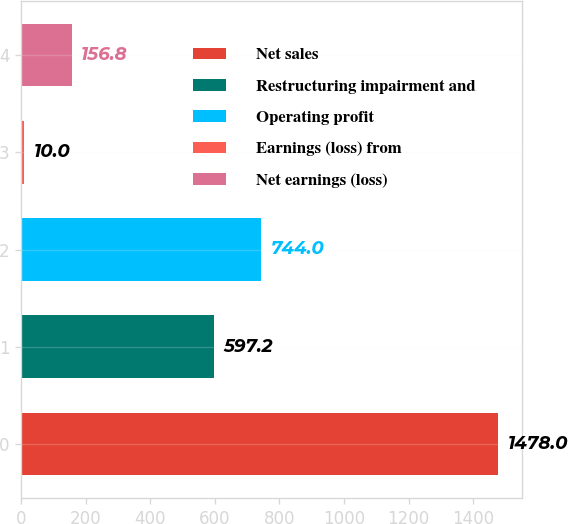Convert chart. <chart><loc_0><loc_0><loc_500><loc_500><bar_chart><fcel>Net sales<fcel>Restructuring impairment and<fcel>Operating profit<fcel>Earnings (loss) from<fcel>Net earnings (loss)<nl><fcel>1478<fcel>597.2<fcel>744<fcel>10<fcel>156.8<nl></chart> 